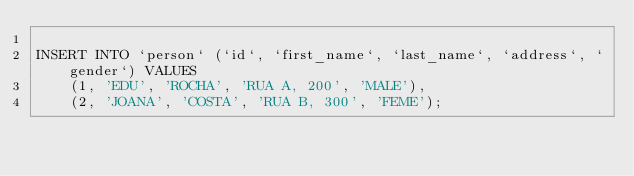Convert code to text. <code><loc_0><loc_0><loc_500><loc_500><_SQL_>
INSERT INTO `person` (`id`, `first_name`, `last_name`, `address`, `gender`) VALUES
	(1, 'EDU', 'ROCHA', 'RUA A, 200', 'MALE'),
	(2, 'JOANA', 'COSTA', 'RUA B, 300', 'FEME');
</code> 